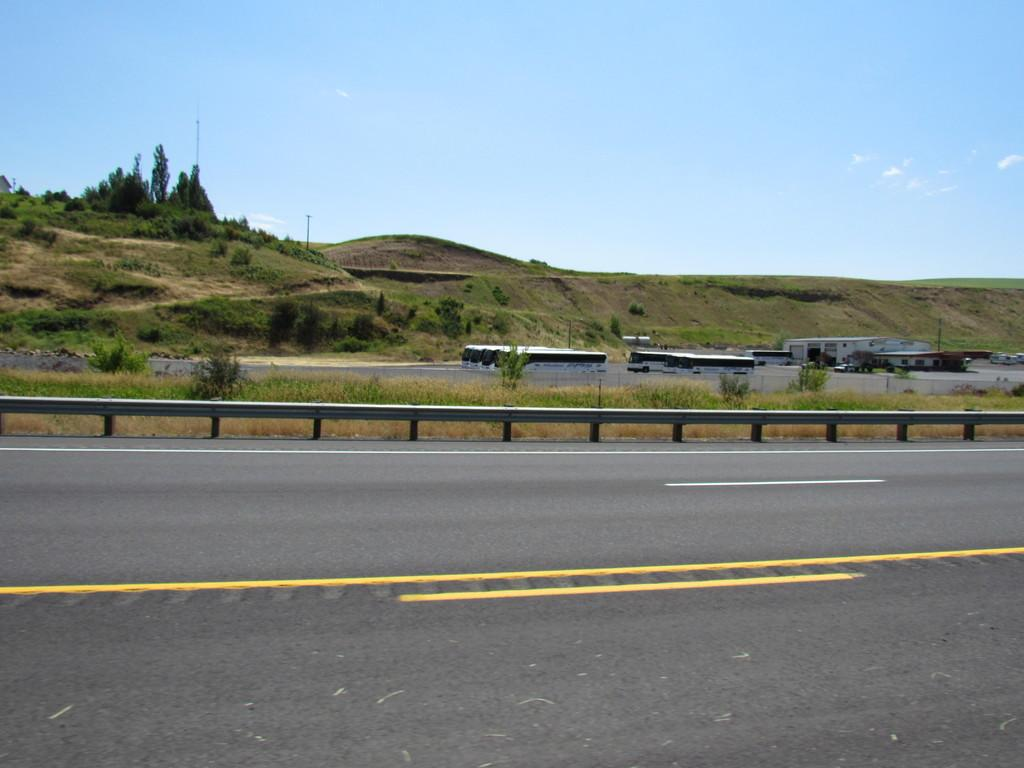What can be seen on the road in the image? There are vehicles on the road in the image. What structures are visible in the image? There are buildings in the image. What type of vegetation is present in the image? There are trees and plants in the image. What part of the natural environment is visible in the image? The sky is visible in the image. What thrill ride can be seen in the image? There is no thrill ride present in the image. What type of system is responsible for the functioning of the vehicles in the image? The image does not provide information about the system responsible for the functioning of the vehicles. 